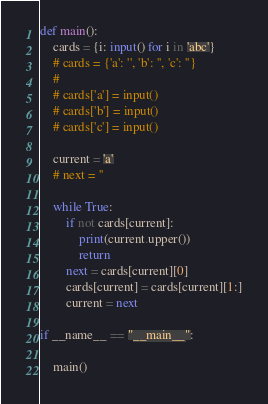<code> <loc_0><loc_0><loc_500><loc_500><_Python_>def main():
    cards = {i: input() for i in 'abc'}
    # cards = {'a': '', 'b': '', 'c': ''}
    # 
    # cards['a'] = input()
    # cards['b'] = input()
    # cards['c'] = input()

    current = 'a'
    # next = ''

    while True:
        if not cards[current]:
            print(current.upper())
            return
        next = cards[current][0]
        cards[current] = cards[current][1:]
        current = next

if __name__ == "__main__":

    main()
</code> 